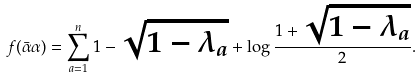Convert formula to latex. <formula><loc_0><loc_0><loc_500><loc_500>f ( \bar { \alpha } \alpha ) = \sum _ { a = 1 } ^ { n } 1 - \sqrt { 1 - \lambda _ { a } } + \log \frac { 1 + \sqrt { 1 - \lambda _ { a } } } { 2 } .</formula> 